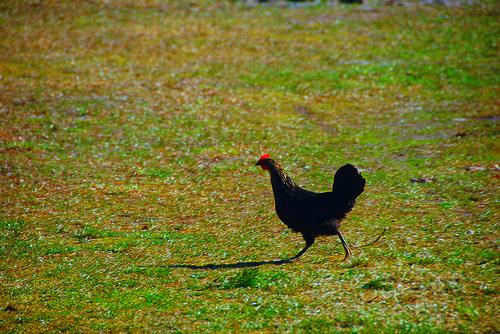<image>
Can you confirm if the hen is on the grass? Yes. Looking at the image, I can see the hen is positioned on top of the grass, with the grass providing support. 